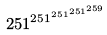Convert formula to latex. <formula><loc_0><loc_0><loc_500><loc_500>2 5 1 ^ { 2 5 1 ^ { 2 5 1 ^ { 2 5 1 ^ { 2 5 9 } } } }</formula> 